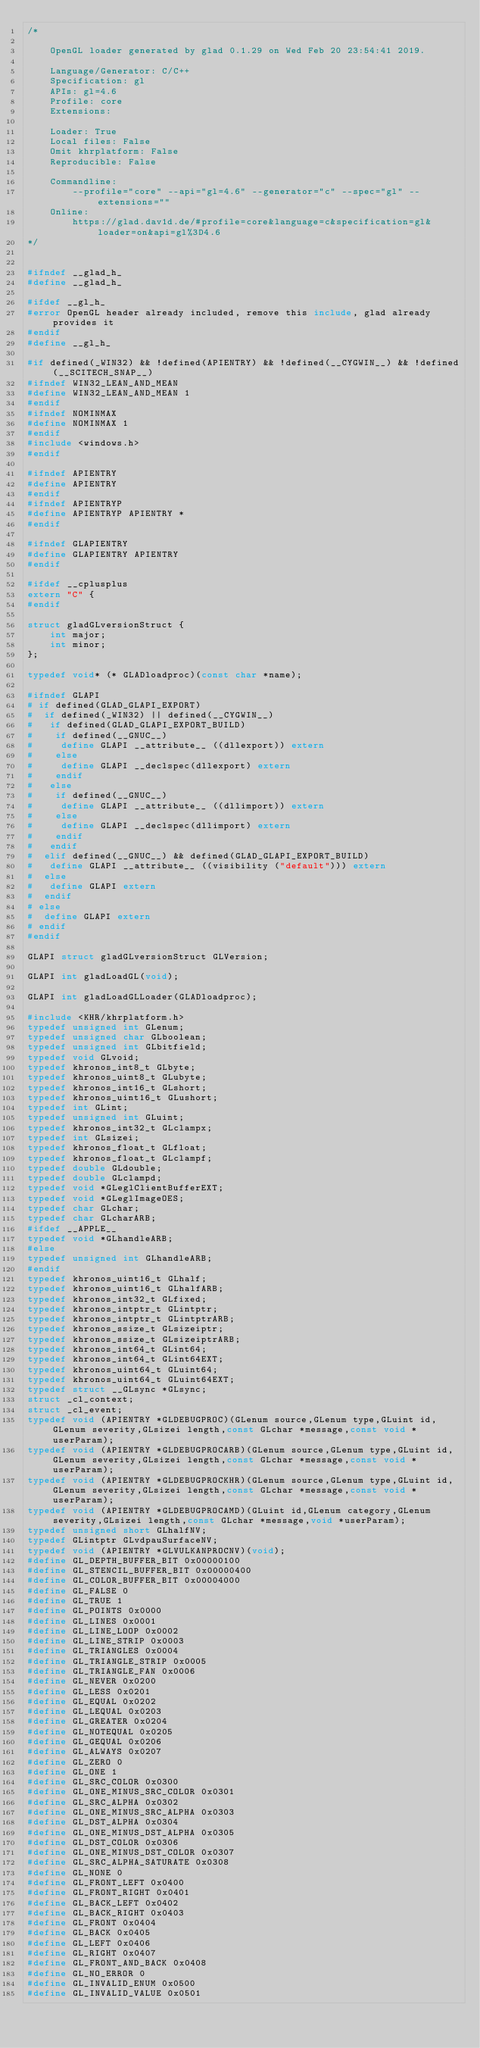<code> <loc_0><loc_0><loc_500><loc_500><_C_>/*

    OpenGL loader generated by glad 0.1.29 on Wed Feb 20 23:54:41 2019.

    Language/Generator: C/C++
    Specification: gl
    APIs: gl=4.6
    Profile: core
    Extensions:
        
    Loader: True
    Local files: False
    Omit khrplatform: False
    Reproducible: False

    Commandline:
        --profile="core" --api="gl=4.6" --generator="c" --spec="gl" --extensions=""
    Online:
        https://glad.dav1d.de/#profile=core&language=c&specification=gl&loader=on&api=gl%3D4.6
*/


#ifndef __glad_h_
#define __glad_h_

#ifdef __gl_h_
#error OpenGL header already included, remove this include, glad already provides it
#endif
#define __gl_h_

#if defined(_WIN32) && !defined(APIENTRY) && !defined(__CYGWIN__) && !defined(__SCITECH_SNAP__)
#ifndef WIN32_LEAN_AND_MEAN
#define WIN32_LEAN_AND_MEAN 1
#endif
#ifndef NOMINMAX
#define NOMINMAX 1
#endif
#include <windows.h>
#endif

#ifndef APIENTRY
#define APIENTRY
#endif
#ifndef APIENTRYP
#define APIENTRYP APIENTRY *
#endif

#ifndef GLAPIENTRY
#define GLAPIENTRY APIENTRY
#endif

#ifdef __cplusplus
extern "C" {
#endif

struct gladGLversionStruct {
    int major;
    int minor;
};

typedef void* (* GLADloadproc)(const char *name);

#ifndef GLAPI
# if defined(GLAD_GLAPI_EXPORT)
#  if defined(_WIN32) || defined(__CYGWIN__)
#   if defined(GLAD_GLAPI_EXPORT_BUILD)
#    if defined(__GNUC__)
#     define GLAPI __attribute__ ((dllexport)) extern
#    else
#     define GLAPI __declspec(dllexport) extern
#    endif
#   else
#    if defined(__GNUC__)
#     define GLAPI __attribute__ ((dllimport)) extern
#    else
#     define GLAPI __declspec(dllimport) extern
#    endif
#   endif
#  elif defined(__GNUC__) && defined(GLAD_GLAPI_EXPORT_BUILD)
#   define GLAPI __attribute__ ((visibility ("default"))) extern
#  else
#   define GLAPI extern
#  endif
# else
#  define GLAPI extern
# endif
#endif

GLAPI struct gladGLversionStruct GLVersion;

GLAPI int gladLoadGL(void);

GLAPI int gladLoadGLLoader(GLADloadproc);

#include <KHR/khrplatform.h>
typedef unsigned int GLenum;
typedef unsigned char GLboolean;
typedef unsigned int GLbitfield;
typedef void GLvoid;
typedef khronos_int8_t GLbyte;
typedef khronos_uint8_t GLubyte;
typedef khronos_int16_t GLshort;
typedef khronos_uint16_t GLushort;
typedef int GLint;
typedef unsigned int GLuint;
typedef khronos_int32_t GLclampx;
typedef int GLsizei;
typedef khronos_float_t GLfloat;
typedef khronos_float_t GLclampf;
typedef double GLdouble;
typedef double GLclampd;
typedef void *GLeglClientBufferEXT;
typedef void *GLeglImageOES;
typedef char GLchar;
typedef char GLcharARB;
#ifdef __APPLE__
typedef void *GLhandleARB;
#else
typedef unsigned int GLhandleARB;
#endif
typedef khronos_uint16_t GLhalf;
typedef khronos_uint16_t GLhalfARB;
typedef khronos_int32_t GLfixed;
typedef khronos_intptr_t GLintptr;
typedef khronos_intptr_t GLintptrARB;
typedef khronos_ssize_t GLsizeiptr;
typedef khronos_ssize_t GLsizeiptrARB;
typedef khronos_int64_t GLint64;
typedef khronos_int64_t GLint64EXT;
typedef khronos_uint64_t GLuint64;
typedef khronos_uint64_t GLuint64EXT;
typedef struct __GLsync *GLsync;
struct _cl_context;
struct _cl_event;
typedef void (APIENTRY *GLDEBUGPROC)(GLenum source,GLenum type,GLuint id,GLenum severity,GLsizei length,const GLchar *message,const void *userParam);
typedef void (APIENTRY *GLDEBUGPROCARB)(GLenum source,GLenum type,GLuint id,GLenum severity,GLsizei length,const GLchar *message,const void *userParam);
typedef void (APIENTRY *GLDEBUGPROCKHR)(GLenum source,GLenum type,GLuint id,GLenum severity,GLsizei length,const GLchar *message,const void *userParam);
typedef void (APIENTRY *GLDEBUGPROCAMD)(GLuint id,GLenum category,GLenum severity,GLsizei length,const GLchar *message,void *userParam);
typedef unsigned short GLhalfNV;
typedef GLintptr GLvdpauSurfaceNV;
typedef void (APIENTRY *GLVULKANPROCNV)(void);
#define GL_DEPTH_BUFFER_BIT 0x00000100
#define GL_STENCIL_BUFFER_BIT 0x00000400
#define GL_COLOR_BUFFER_BIT 0x00004000
#define GL_FALSE 0
#define GL_TRUE 1
#define GL_POINTS 0x0000
#define GL_LINES 0x0001
#define GL_LINE_LOOP 0x0002
#define GL_LINE_STRIP 0x0003
#define GL_TRIANGLES 0x0004
#define GL_TRIANGLE_STRIP 0x0005
#define GL_TRIANGLE_FAN 0x0006
#define GL_NEVER 0x0200
#define GL_LESS 0x0201
#define GL_EQUAL 0x0202
#define GL_LEQUAL 0x0203
#define GL_GREATER 0x0204
#define GL_NOTEQUAL 0x0205
#define GL_GEQUAL 0x0206
#define GL_ALWAYS 0x0207
#define GL_ZERO 0
#define GL_ONE 1
#define GL_SRC_COLOR 0x0300
#define GL_ONE_MINUS_SRC_COLOR 0x0301
#define GL_SRC_ALPHA 0x0302
#define GL_ONE_MINUS_SRC_ALPHA 0x0303
#define GL_DST_ALPHA 0x0304
#define GL_ONE_MINUS_DST_ALPHA 0x0305
#define GL_DST_COLOR 0x0306
#define GL_ONE_MINUS_DST_COLOR 0x0307
#define GL_SRC_ALPHA_SATURATE 0x0308
#define GL_NONE 0
#define GL_FRONT_LEFT 0x0400
#define GL_FRONT_RIGHT 0x0401
#define GL_BACK_LEFT 0x0402
#define GL_BACK_RIGHT 0x0403
#define GL_FRONT 0x0404
#define GL_BACK 0x0405
#define GL_LEFT 0x0406
#define GL_RIGHT 0x0407
#define GL_FRONT_AND_BACK 0x0408
#define GL_NO_ERROR 0
#define GL_INVALID_ENUM 0x0500
#define GL_INVALID_VALUE 0x0501</code> 